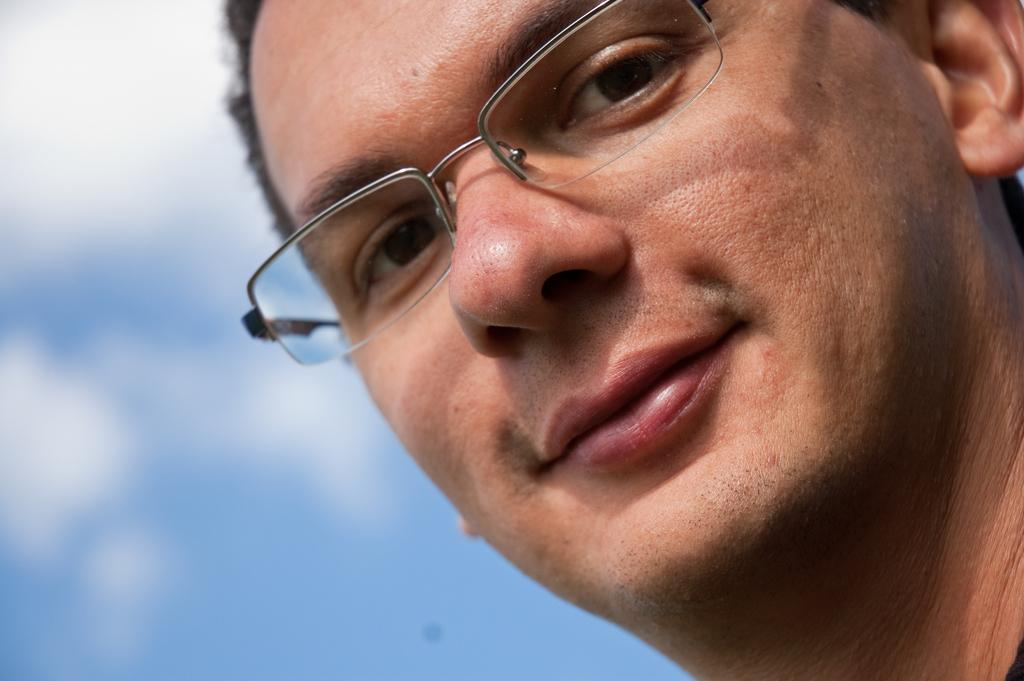Who is present in the image? There is a man in the image. What accessory is the man wearing? The man is wearing spectacles. Can you describe the background of the image? The background of the image is blurred. What type of crown is the man wearing in the image? There is no crown present in the image; the man is wearing spectacles. 